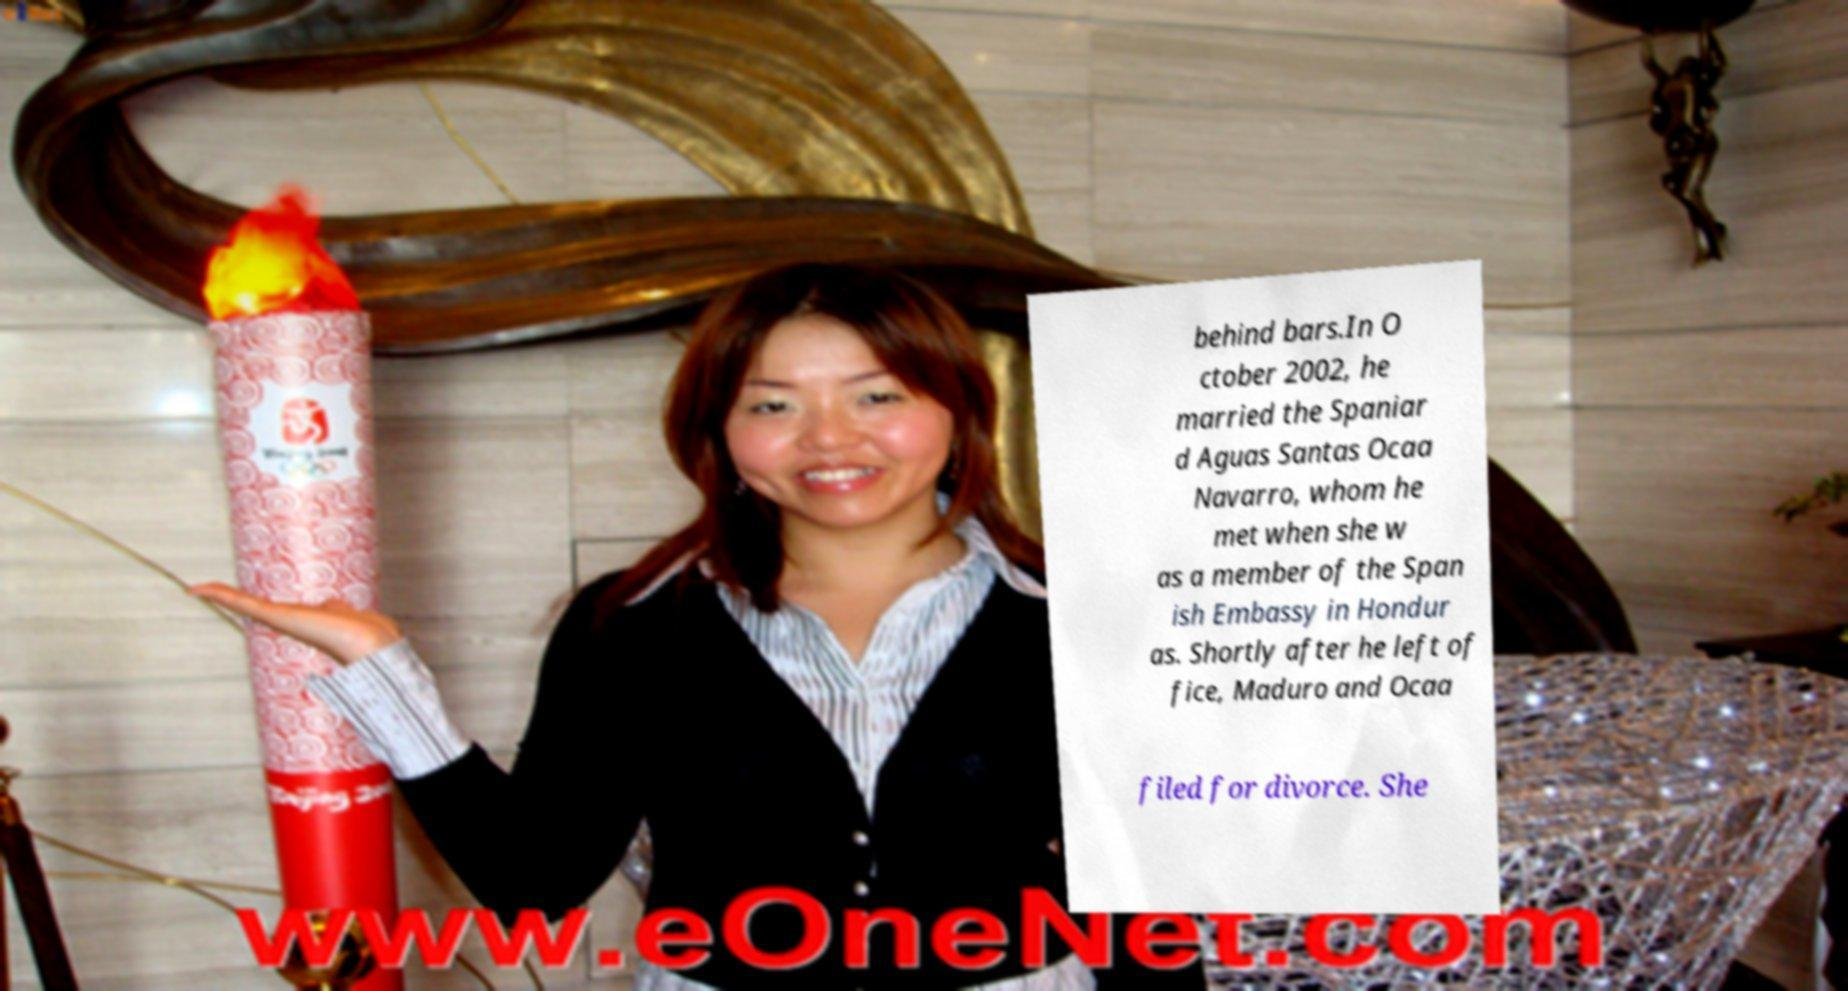Could you extract and type out the text from this image? behind bars.In O ctober 2002, he married the Spaniar d Aguas Santas Ocaa Navarro, whom he met when she w as a member of the Span ish Embassy in Hondur as. Shortly after he left of fice, Maduro and Ocaa filed for divorce. She 